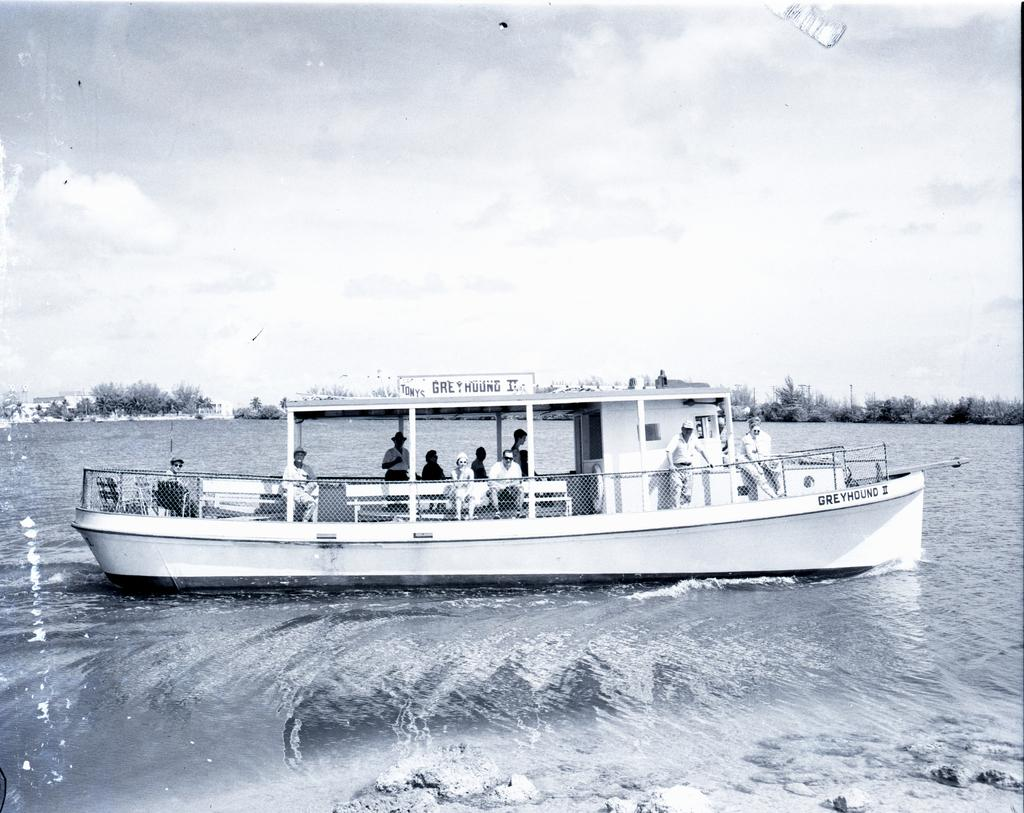What is the main subject in the center of the image? There is a ship in the center of the image. Can you describe the people inside the ship? There are people inside the ship, but their specific actions or appearances are not mentioned in the facts. What can be seen in the background of the image? There are trees in the background of the image. How would you describe the sky in the image? The sky is cloudy in the image. What type of underwear is the person on the ship wearing? There is no information about the clothing of the people inside the ship, so it cannot be determined from the image. How is the quilt being used on the ship? There is no mention of a quilt in the image, so it cannot be determined how it might be used. 